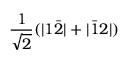<formula> <loc_0><loc_0><loc_500><loc_500>\frac { 1 } { \sqrt { 2 } } ( | 1 \bar { 2 } | + | \bar { 1 } 2 | )</formula> 